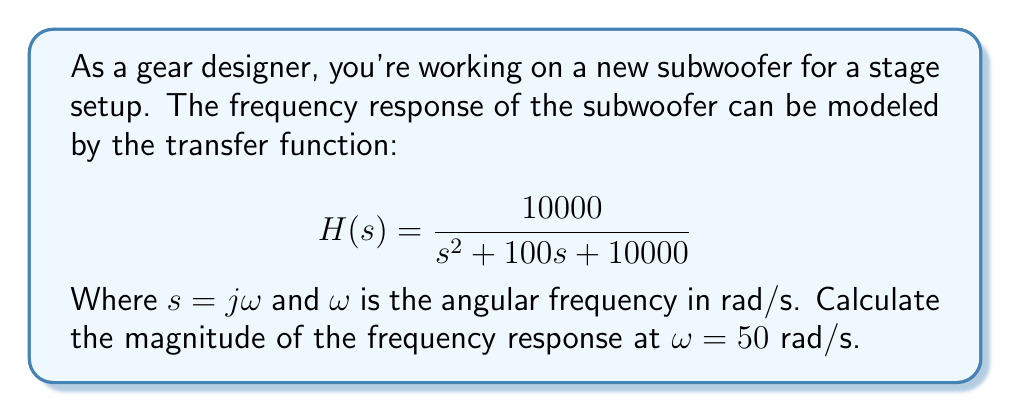Solve this math problem. To solve this problem, we'll follow these steps:

1) First, we substitute $s = j\omega$ into the transfer function:

   $$H(j\omega) = \frac{10000}{(j\omega)^2 + 100(j\omega) + 10000}$$

2) Now, we substitute $\omega = 50$ rad/s:

   $$H(j50) = \frac{10000}{(j50)^2 + 100(j50) + 10000}$$

3) Simplify the denominator:

   $$H(j50) = \frac{10000}{-2500 + 5000j + 10000}$$

4) Combine like terms:

   $$H(j50) = \frac{10000}{7500 + 5000j}$$

5) To find the magnitude, we use the formula $|H(j\omega)| = \sqrt{\text{Re}^2 + \text{Im}^2}$:

   $$|H(j50)| = \left|\frac{10000}{7500 + 5000j}\right|$$

6) Multiply numerator and denominator by the complex conjugate of the denominator:

   $$|H(j50)| = \sqrt{\frac{10000^2}{7500^2 + 5000^2}}$$

7) Calculate:

   $$|H(j50)| = \sqrt{\frac{100000000}{56250000 + 25000000}} = \sqrt{\frac{100000000}{81250000}}$$

8) Simplify:

   $$|H(j50)| = \sqrt{\frac{40}{33}} \approx 1.1018$$
Answer: $\sqrt{\frac{40}{33}} \approx 1.1018$ 